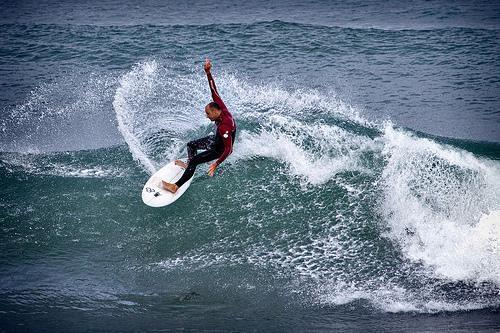How many people are in the picture?
Give a very brief answer. 1. 